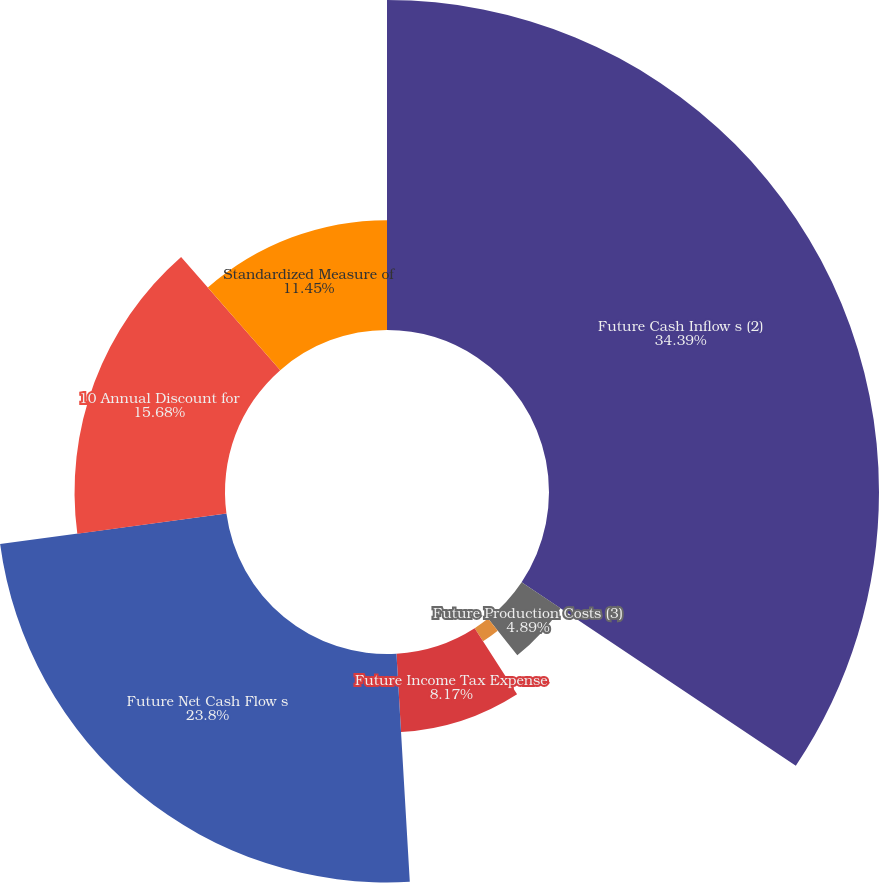Convert chart. <chart><loc_0><loc_0><loc_500><loc_500><pie_chart><fcel>Future Cash Inflow s (2)<fcel>Future Production Costs (3)<fcel>Future Development Costs<fcel>Future Income Tax Expense<fcel>Future Net Cash Flow s<fcel>10 Annual Discount for<fcel>Standardized Measure of<nl><fcel>34.39%<fcel>4.89%<fcel>1.62%<fcel>8.17%<fcel>23.8%<fcel>15.68%<fcel>11.45%<nl></chart> 